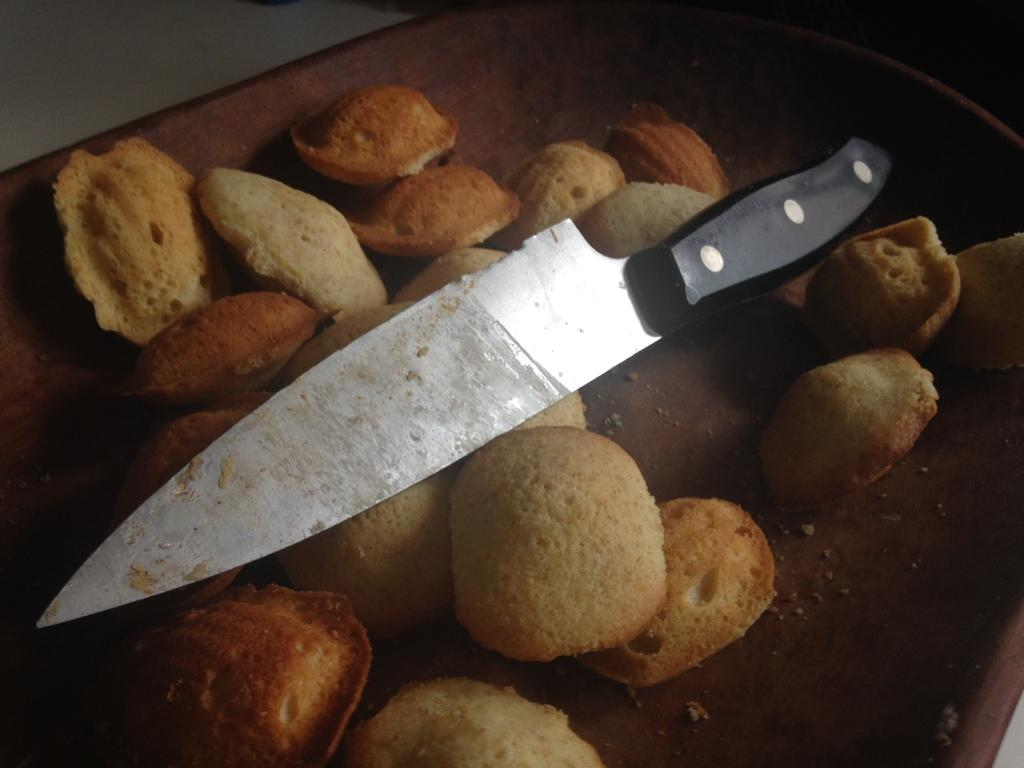What can be seen in the image related to food preparation? There is food, a knife, and a chopping board in the image. Where is the chopping board placed? The chopping board is on a white surface. What might be used to cut or slice the food in the image? The knife in the image can be used to cut or slice the food. What type of cork can be seen floating in the food in the image? There is no cork present in the image; it only features food, a knife, and a chopping board. 